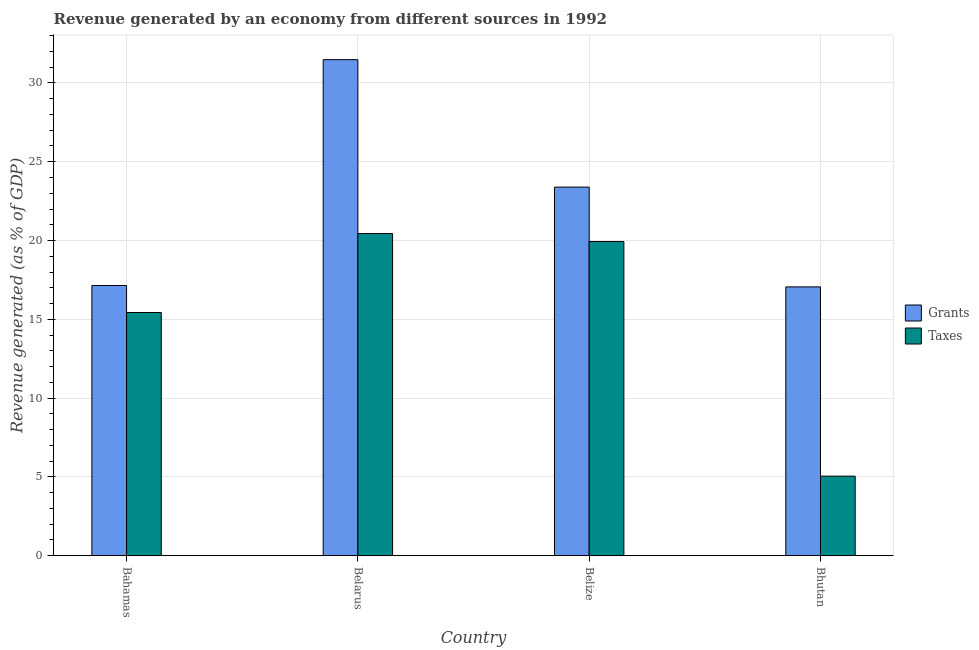How many different coloured bars are there?
Your answer should be very brief. 2. How many groups of bars are there?
Offer a very short reply. 4. Are the number of bars per tick equal to the number of legend labels?
Offer a very short reply. Yes. How many bars are there on the 2nd tick from the right?
Make the answer very short. 2. What is the label of the 4th group of bars from the left?
Provide a succinct answer. Bhutan. What is the revenue generated by taxes in Bhutan?
Your response must be concise. 5.05. Across all countries, what is the maximum revenue generated by grants?
Make the answer very short. 31.48. Across all countries, what is the minimum revenue generated by taxes?
Offer a terse response. 5.05. In which country was the revenue generated by taxes maximum?
Offer a terse response. Belarus. In which country was the revenue generated by taxes minimum?
Your response must be concise. Bhutan. What is the total revenue generated by grants in the graph?
Keep it short and to the point. 89.07. What is the difference between the revenue generated by taxes in Belarus and that in Bhutan?
Give a very brief answer. 15.39. What is the difference between the revenue generated by grants in Belize and the revenue generated by taxes in Bhutan?
Your answer should be very brief. 18.34. What is the average revenue generated by grants per country?
Make the answer very short. 22.27. What is the difference between the revenue generated by grants and revenue generated by taxes in Bahamas?
Your answer should be compact. 1.71. What is the ratio of the revenue generated by grants in Bahamas to that in Bhutan?
Your answer should be very brief. 1.01. Is the difference between the revenue generated by taxes in Belarus and Bhutan greater than the difference between the revenue generated by grants in Belarus and Bhutan?
Provide a succinct answer. Yes. What is the difference between the highest and the second highest revenue generated by taxes?
Keep it short and to the point. 0.51. What is the difference between the highest and the lowest revenue generated by grants?
Ensure brevity in your answer.  14.42. Is the sum of the revenue generated by taxes in Belarus and Belize greater than the maximum revenue generated by grants across all countries?
Your answer should be compact. Yes. What does the 1st bar from the left in Bhutan represents?
Ensure brevity in your answer.  Grants. What does the 2nd bar from the right in Belarus represents?
Provide a succinct answer. Grants. How many bars are there?
Make the answer very short. 8. How many countries are there in the graph?
Make the answer very short. 4. What is the difference between two consecutive major ticks on the Y-axis?
Give a very brief answer. 5. Where does the legend appear in the graph?
Your answer should be compact. Center right. How are the legend labels stacked?
Offer a terse response. Vertical. What is the title of the graph?
Give a very brief answer. Revenue generated by an economy from different sources in 1992. What is the label or title of the Y-axis?
Ensure brevity in your answer.  Revenue generated (as % of GDP). What is the Revenue generated (as % of GDP) in Grants in Bahamas?
Your answer should be compact. 17.15. What is the Revenue generated (as % of GDP) in Taxes in Bahamas?
Provide a succinct answer. 15.43. What is the Revenue generated (as % of GDP) in Grants in Belarus?
Your answer should be compact. 31.48. What is the Revenue generated (as % of GDP) in Taxes in Belarus?
Give a very brief answer. 20.44. What is the Revenue generated (as % of GDP) of Grants in Belize?
Provide a succinct answer. 23.39. What is the Revenue generated (as % of GDP) in Taxes in Belize?
Your answer should be compact. 19.94. What is the Revenue generated (as % of GDP) in Grants in Bhutan?
Your response must be concise. 17.06. What is the Revenue generated (as % of GDP) of Taxes in Bhutan?
Keep it short and to the point. 5.05. Across all countries, what is the maximum Revenue generated (as % of GDP) of Grants?
Ensure brevity in your answer.  31.48. Across all countries, what is the maximum Revenue generated (as % of GDP) in Taxes?
Provide a succinct answer. 20.44. Across all countries, what is the minimum Revenue generated (as % of GDP) in Grants?
Your answer should be very brief. 17.06. Across all countries, what is the minimum Revenue generated (as % of GDP) in Taxes?
Give a very brief answer. 5.05. What is the total Revenue generated (as % of GDP) of Grants in the graph?
Ensure brevity in your answer.  89.07. What is the total Revenue generated (as % of GDP) in Taxes in the graph?
Make the answer very short. 60.86. What is the difference between the Revenue generated (as % of GDP) in Grants in Bahamas and that in Belarus?
Offer a terse response. -14.33. What is the difference between the Revenue generated (as % of GDP) in Taxes in Bahamas and that in Belarus?
Your response must be concise. -5.01. What is the difference between the Revenue generated (as % of GDP) in Grants in Bahamas and that in Belize?
Give a very brief answer. -6.24. What is the difference between the Revenue generated (as % of GDP) of Taxes in Bahamas and that in Belize?
Your answer should be compact. -4.5. What is the difference between the Revenue generated (as % of GDP) of Grants in Bahamas and that in Bhutan?
Ensure brevity in your answer.  0.09. What is the difference between the Revenue generated (as % of GDP) of Taxes in Bahamas and that in Bhutan?
Offer a very short reply. 10.38. What is the difference between the Revenue generated (as % of GDP) of Grants in Belarus and that in Belize?
Offer a terse response. 8.09. What is the difference between the Revenue generated (as % of GDP) of Taxes in Belarus and that in Belize?
Offer a very short reply. 0.51. What is the difference between the Revenue generated (as % of GDP) of Grants in Belarus and that in Bhutan?
Your response must be concise. 14.42. What is the difference between the Revenue generated (as % of GDP) in Taxes in Belarus and that in Bhutan?
Ensure brevity in your answer.  15.39. What is the difference between the Revenue generated (as % of GDP) in Grants in Belize and that in Bhutan?
Provide a short and direct response. 6.33. What is the difference between the Revenue generated (as % of GDP) in Taxes in Belize and that in Bhutan?
Make the answer very short. 14.89. What is the difference between the Revenue generated (as % of GDP) of Grants in Bahamas and the Revenue generated (as % of GDP) of Taxes in Belarus?
Offer a very short reply. -3.3. What is the difference between the Revenue generated (as % of GDP) in Grants in Bahamas and the Revenue generated (as % of GDP) in Taxes in Belize?
Your answer should be compact. -2.79. What is the difference between the Revenue generated (as % of GDP) of Grants in Bahamas and the Revenue generated (as % of GDP) of Taxes in Bhutan?
Offer a very short reply. 12.1. What is the difference between the Revenue generated (as % of GDP) in Grants in Belarus and the Revenue generated (as % of GDP) in Taxes in Belize?
Offer a terse response. 11.54. What is the difference between the Revenue generated (as % of GDP) of Grants in Belarus and the Revenue generated (as % of GDP) of Taxes in Bhutan?
Give a very brief answer. 26.43. What is the difference between the Revenue generated (as % of GDP) of Grants in Belize and the Revenue generated (as % of GDP) of Taxes in Bhutan?
Your response must be concise. 18.34. What is the average Revenue generated (as % of GDP) of Grants per country?
Ensure brevity in your answer.  22.27. What is the average Revenue generated (as % of GDP) of Taxes per country?
Keep it short and to the point. 15.22. What is the difference between the Revenue generated (as % of GDP) in Grants and Revenue generated (as % of GDP) in Taxes in Bahamas?
Ensure brevity in your answer.  1.71. What is the difference between the Revenue generated (as % of GDP) of Grants and Revenue generated (as % of GDP) of Taxes in Belarus?
Make the answer very short. 11.03. What is the difference between the Revenue generated (as % of GDP) of Grants and Revenue generated (as % of GDP) of Taxes in Belize?
Make the answer very short. 3.45. What is the difference between the Revenue generated (as % of GDP) of Grants and Revenue generated (as % of GDP) of Taxes in Bhutan?
Provide a succinct answer. 12.01. What is the ratio of the Revenue generated (as % of GDP) in Grants in Bahamas to that in Belarus?
Make the answer very short. 0.54. What is the ratio of the Revenue generated (as % of GDP) in Taxes in Bahamas to that in Belarus?
Make the answer very short. 0.75. What is the ratio of the Revenue generated (as % of GDP) in Grants in Bahamas to that in Belize?
Provide a succinct answer. 0.73. What is the ratio of the Revenue generated (as % of GDP) of Taxes in Bahamas to that in Belize?
Ensure brevity in your answer.  0.77. What is the ratio of the Revenue generated (as % of GDP) in Taxes in Bahamas to that in Bhutan?
Your answer should be compact. 3.06. What is the ratio of the Revenue generated (as % of GDP) of Grants in Belarus to that in Belize?
Give a very brief answer. 1.35. What is the ratio of the Revenue generated (as % of GDP) in Taxes in Belarus to that in Belize?
Provide a succinct answer. 1.03. What is the ratio of the Revenue generated (as % of GDP) of Grants in Belarus to that in Bhutan?
Your answer should be compact. 1.85. What is the ratio of the Revenue generated (as % of GDP) in Taxes in Belarus to that in Bhutan?
Ensure brevity in your answer.  4.05. What is the ratio of the Revenue generated (as % of GDP) in Grants in Belize to that in Bhutan?
Provide a succinct answer. 1.37. What is the ratio of the Revenue generated (as % of GDP) of Taxes in Belize to that in Bhutan?
Provide a short and direct response. 3.95. What is the difference between the highest and the second highest Revenue generated (as % of GDP) of Grants?
Provide a short and direct response. 8.09. What is the difference between the highest and the second highest Revenue generated (as % of GDP) of Taxes?
Give a very brief answer. 0.51. What is the difference between the highest and the lowest Revenue generated (as % of GDP) in Grants?
Your response must be concise. 14.42. What is the difference between the highest and the lowest Revenue generated (as % of GDP) of Taxes?
Make the answer very short. 15.39. 